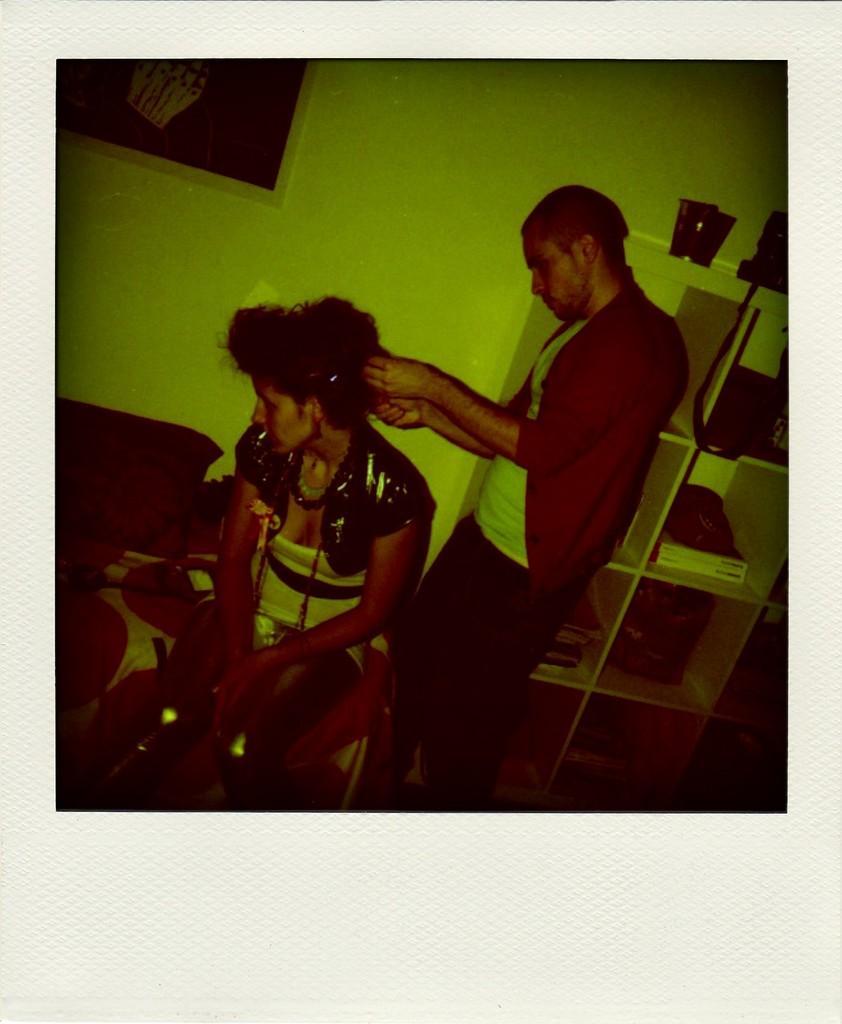Please provide a concise description of this image. This picture shows a man standing and a woman seated and we see cupboards on the side and a frame on the wall and we see man holding the hair of the woman with his hands. 